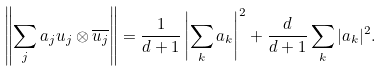Convert formula to latex. <formula><loc_0><loc_0><loc_500><loc_500>\left \| \sum _ { j } a _ { j } u _ { j } \otimes \overline { u _ { j } } \right \| = \frac { 1 } { d + 1 } \left | \sum _ { k } a _ { k } \right | ^ { 2 } + \frac { d } { d + 1 } \sum _ { k } | a _ { k } | ^ { 2 } .</formula> 